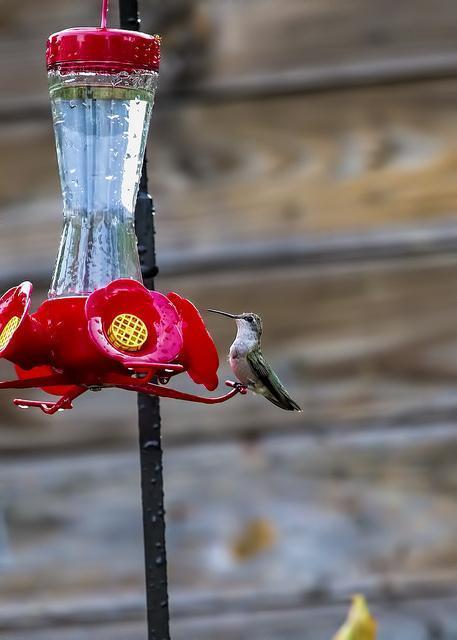How many birds are in the picture?
Give a very brief answer. 1. 